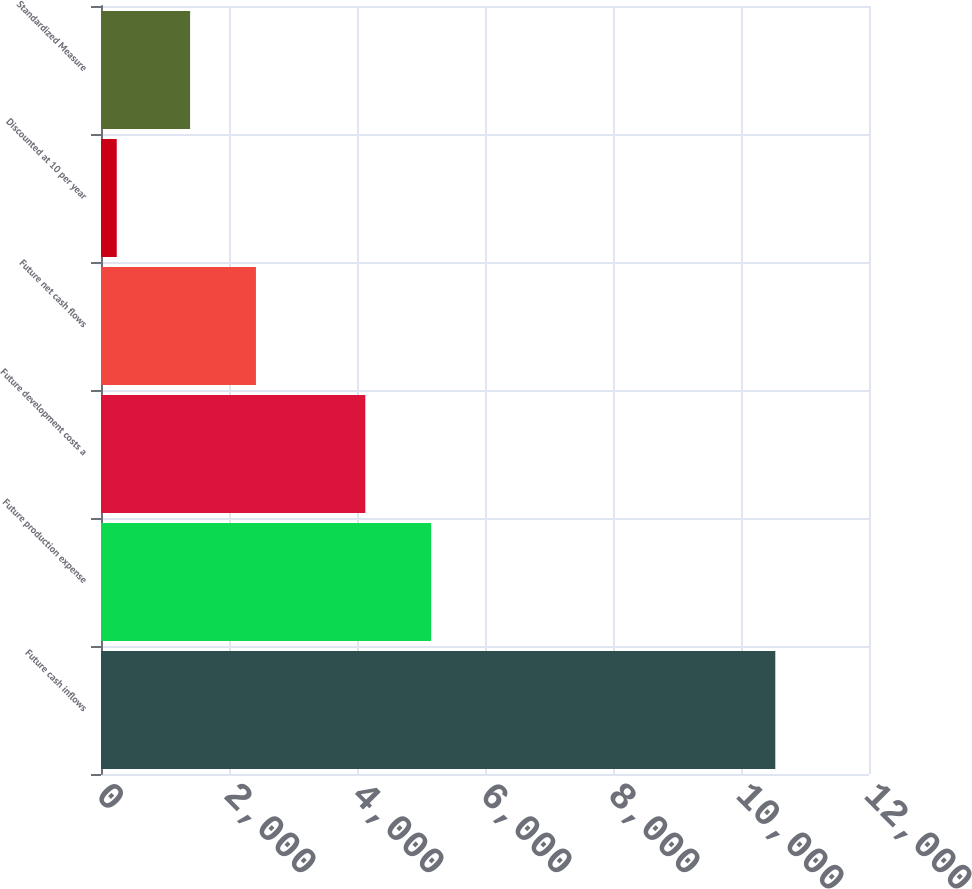Convert chart. <chart><loc_0><loc_0><loc_500><loc_500><bar_chart><fcel>Future cash inflows<fcel>Future production expense<fcel>Future development costs a<fcel>Future net cash flows<fcel>Discounted at 10 per year<fcel>Standardized Measure<nl><fcel>10536<fcel>5159<fcel>4130<fcel>2421<fcel>246<fcel>1392<nl></chart> 